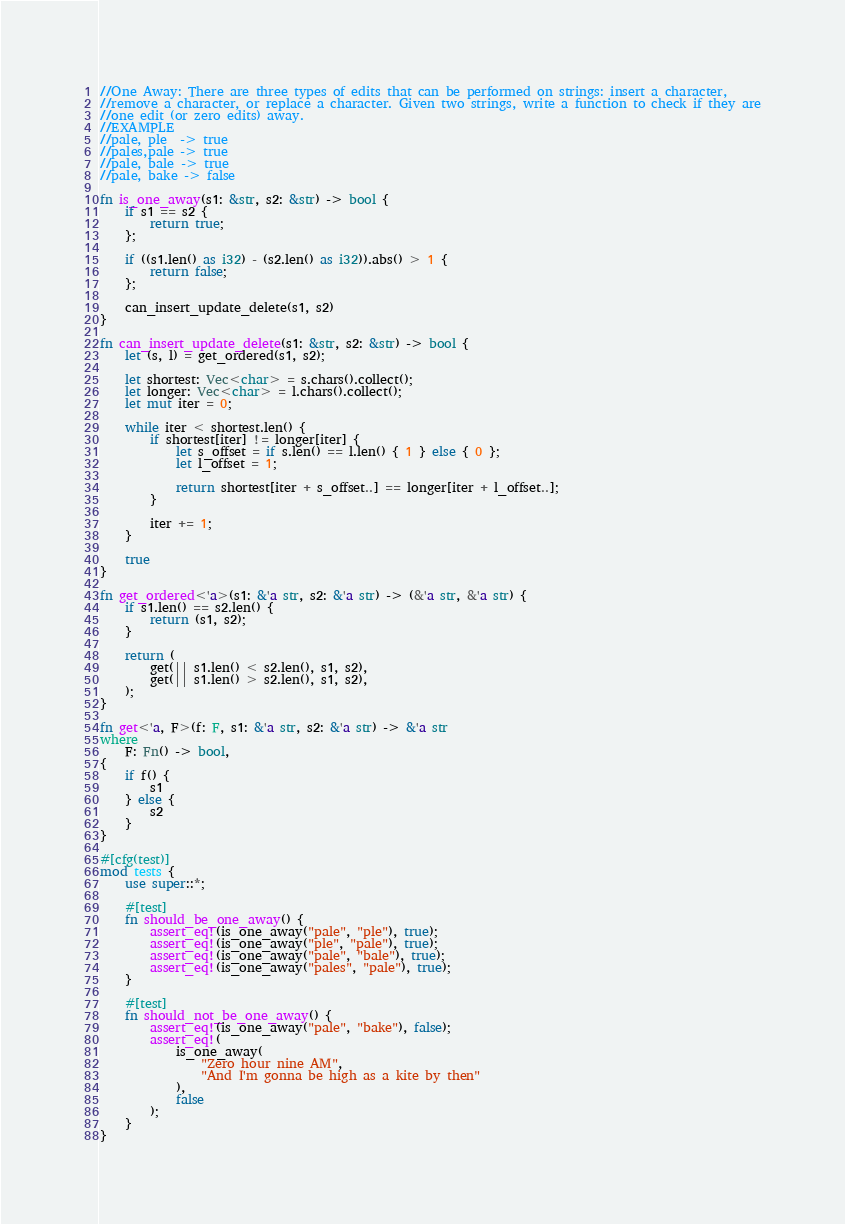<code> <loc_0><loc_0><loc_500><loc_500><_Rust_>//One Away: There are three types of edits that can be performed on strings: insert a character,
//remove a character, or replace a character. Given two strings, write a function to check if they are
//one edit (or zero edits) away.
//EXAMPLE
//pale, ple  -> true
//pales,pale -> true
//pale, bale -> true
//pale, bake -> false

fn is_one_away(s1: &str, s2: &str) -> bool {
    if s1 == s2 {
        return true;
    };

    if ((s1.len() as i32) - (s2.len() as i32)).abs() > 1 {
        return false;
    };

    can_insert_update_delete(s1, s2)
}

fn can_insert_update_delete(s1: &str, s2: &str) -> bool {
    let (s, l) = get_ordered(s1, s2);

    let shortest: Vec<char> = s.chars().collect();
    let longer: Vec<char> = l.chars().collect();
    let mut iter = 0;

    while iter < shortest.len() {
        if shortest[iter] != longer[iter] {
            let s_offset = if s.len() == l.len() { 1 } else { 0 };
            let l_offset = 1;

            return shortest[iter + s_offset..] == longer[iter + l_offset..];
        }

        iter += 1;
    }

    true
}

fn get_ordered<'a>(s1: &'a str, s2: &'a str) -> (&'a str, &'a str) {
    if s1.len() == s2.len() {
        return (s1, s2);
    }

    return (
        get(|| s1.len() < s2.len(), s1, s2),
        get(|| s1.len() > s2.len(), s1, s2),
    );
}

fn get<'a, F>(f: F, s1: &'a str, s2: &'a str) -> &'a str
where
    F: Fn() -> bool,
{
    if f() {
        s1
    } else {
        s2
    }
}

#[cfg(test)]
mod tests {
    use super::*;

    #[test]
    fn should_be_one_away() {
        assert_eq!(is_one_away("pale", "ple"), true);
        assert_eq!(is_one_away("ple", "pale"), true);
        assert_eq!(is_one_away("pale", "bale"), true);
        assert_eq!(is_one_away("pales", "pale"), true);
    }

    #[test]
    fn should_not_be_one_away() {
        assert_eq!(is_one_away("pale", "bake"), false);
        assert_eq!(
            is_one_away(
                "Zero hour nine AM",
                "And I'm gonna be high as a kite by then"
            ),
            false
        );
    }
}
</code> 